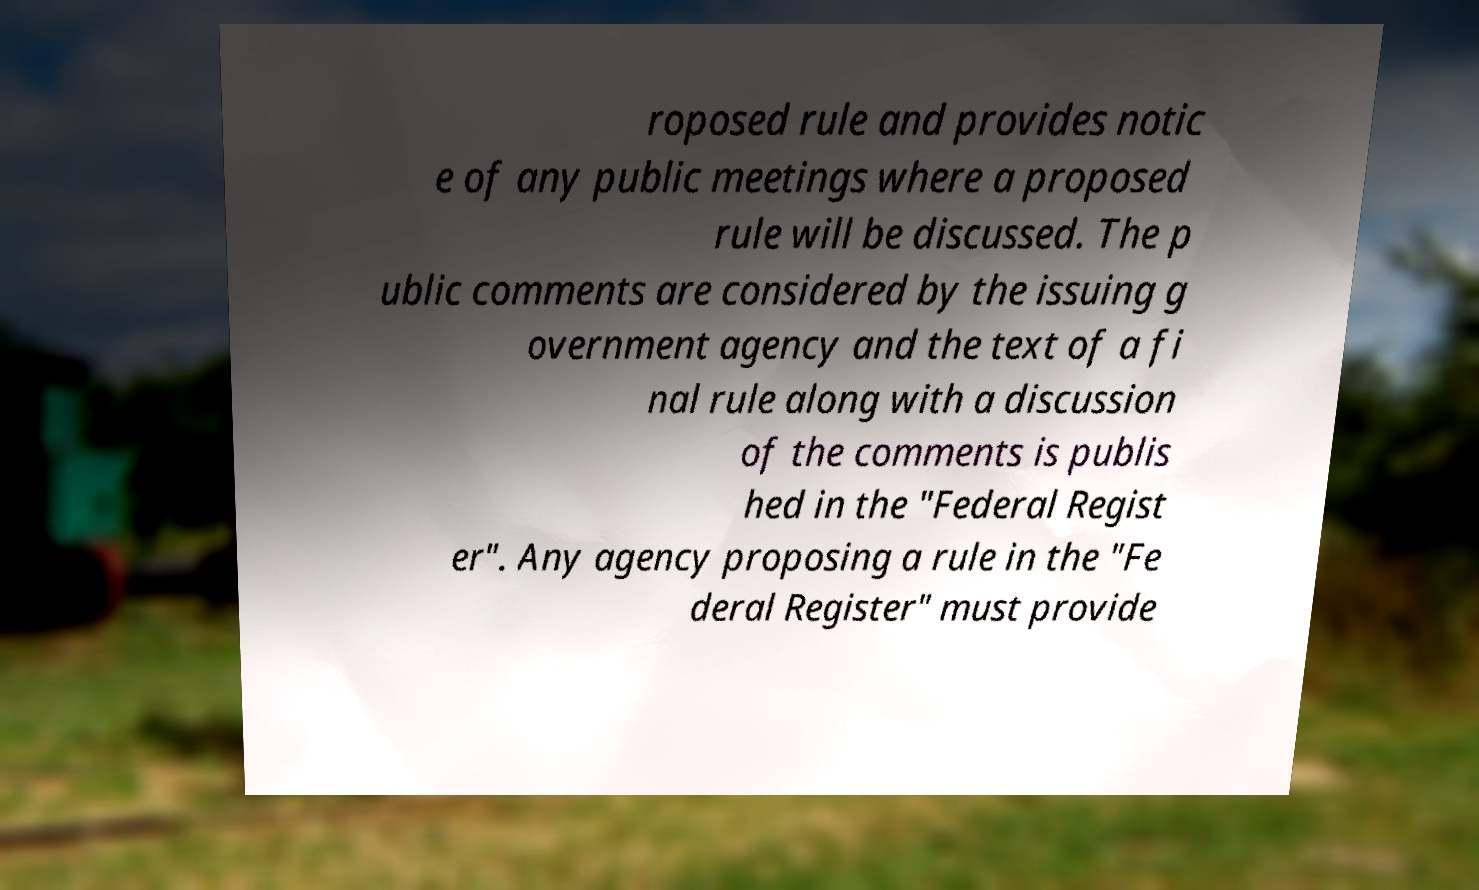Could you extract and type out the text from this image? roposed rule and provides notic e of any public meetings where a proposed rule will be discussed. The p ublic comments are considered by the issuing g overnment agency and the text of a fi nal rule along with a discussion of the comments is publis hed in the "Federal Regist er". Any agency proposing a rule in the "Fe deral Register" must provide 